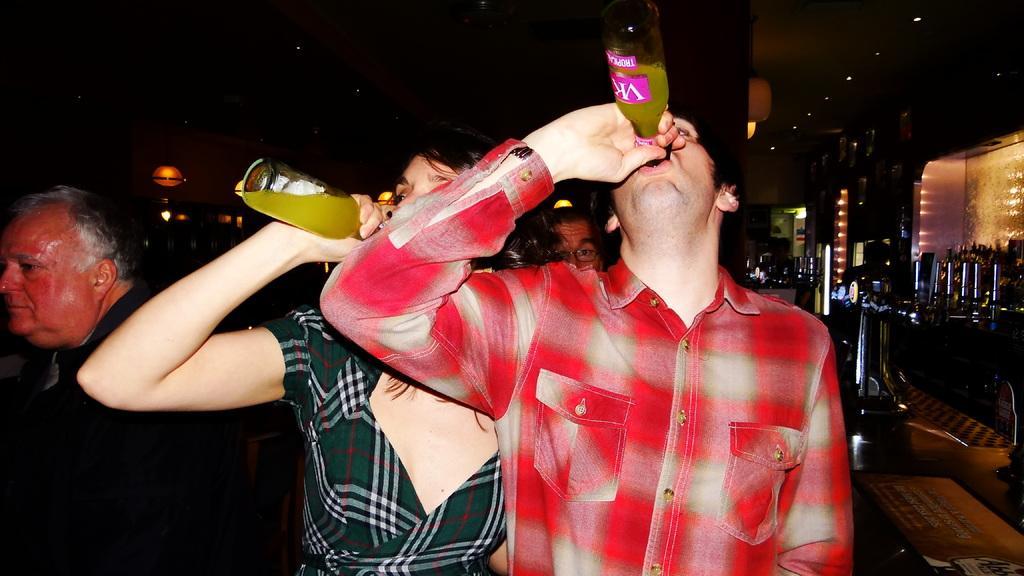How would you summarize this image in a sentence or two? On the right side, there is a person in a shirt, holding a bottle and drinking. Beside him, there is a woman holding a bottle and drinking. On the left side, there is a person. In the background, there is another person, there are buildings having lights, there are poles and trees. And the background is dark in color. 